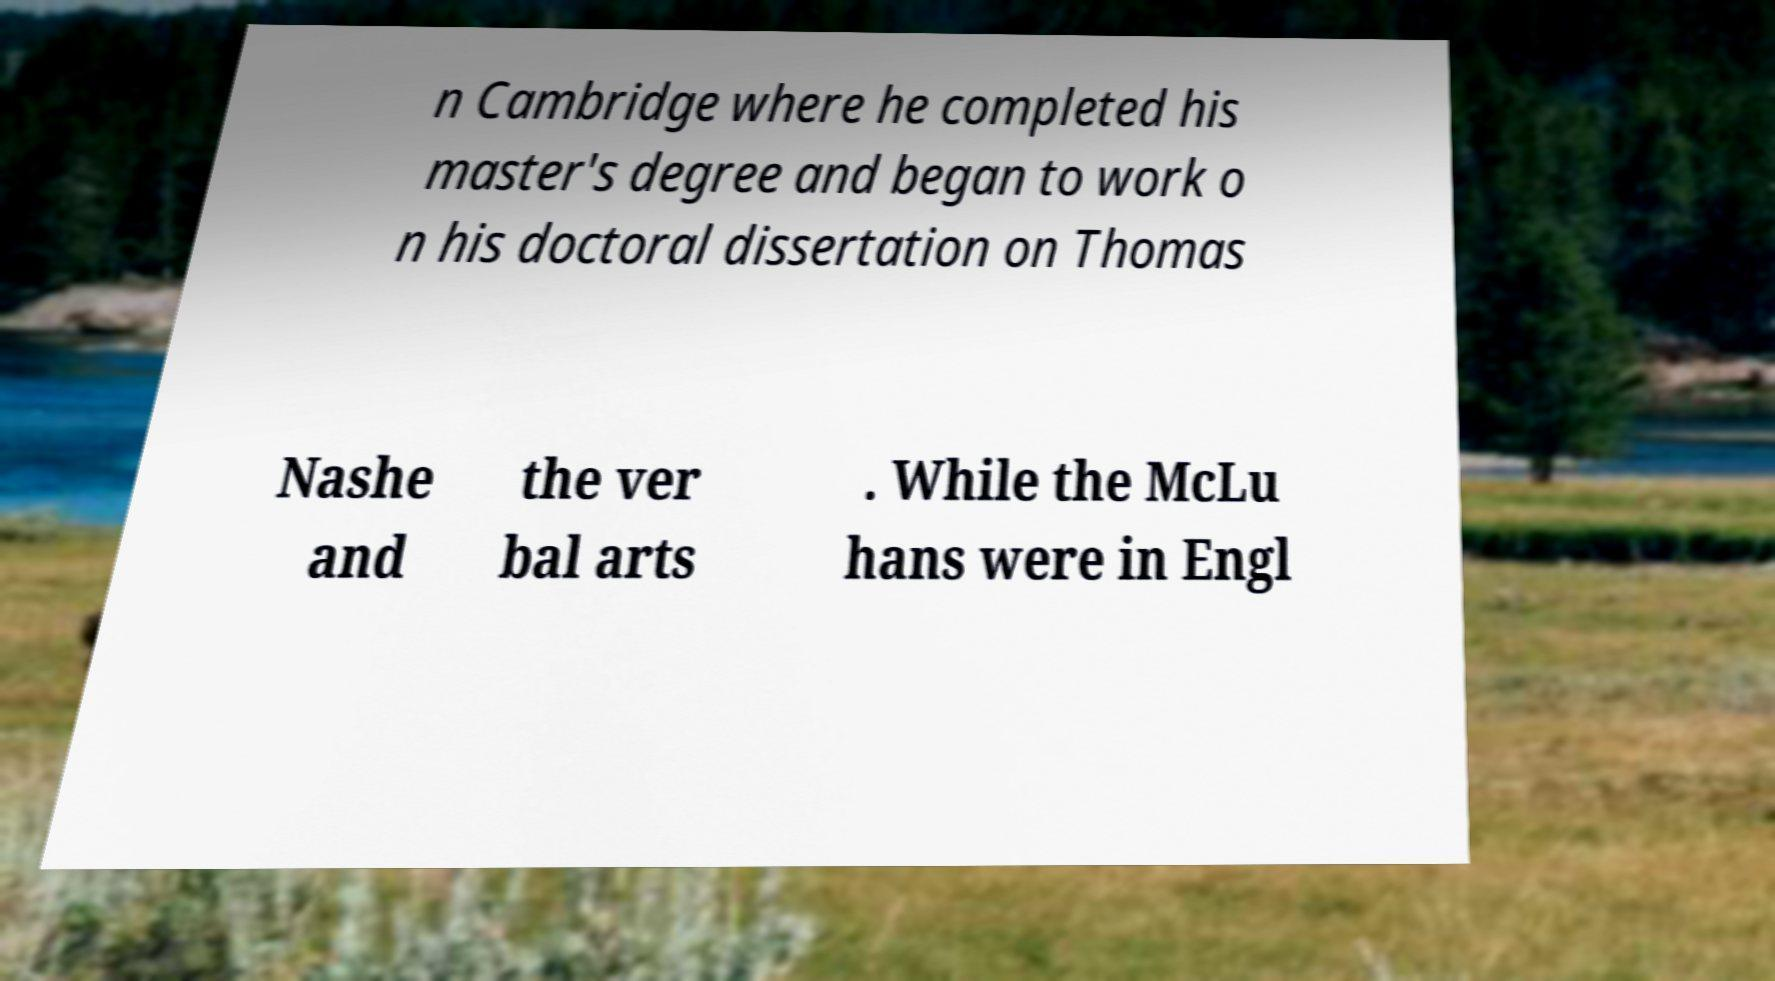Please read and relay the text visible in this image. What does it say? n Cambridge where he completed his master's degree and began to work o n his doctoral dissertation on Thomas Nashe and the ver bal arts . While the McLu hans were in Engl 